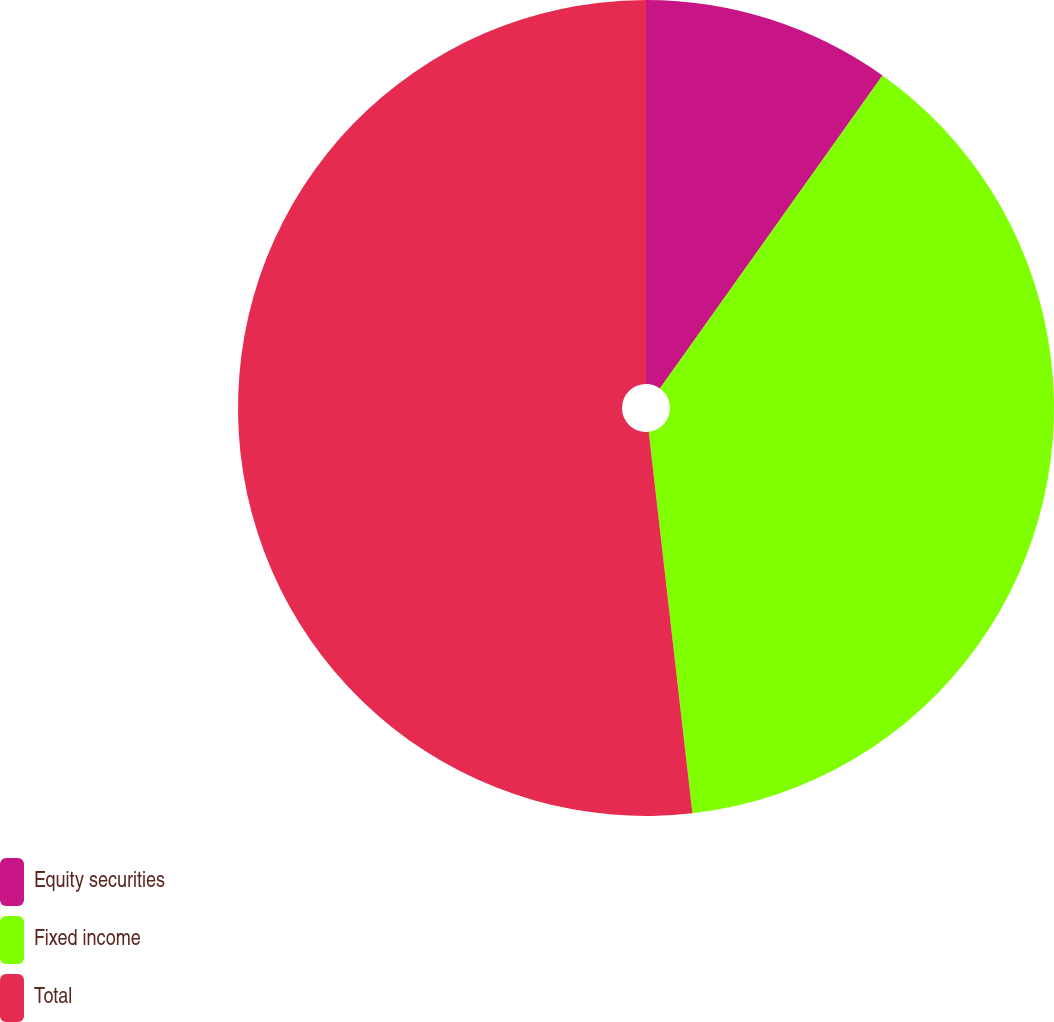Convert chart. <chart><loc_0><loc_0><loc_500><loc_500><pie_chart><fcel>Equity securities<fcel>Fixed income<fcel>Total<nl><fcel>9.84%<fcel>38.34%<fcel>51.81%<nl></chart> 